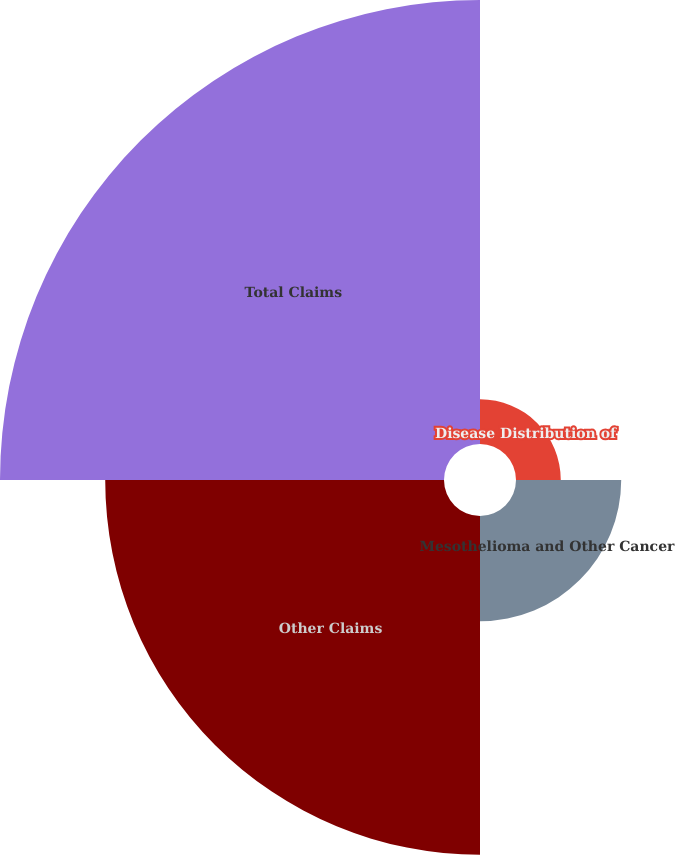<chart> <loc_0><loc_0><loc_500><loc_500><pie_chart><fcel>Disease Distribution of<fcel>Mesothelioma and Other Cancer<fcel>Other Claims<fcel>Total Claims<nl><fcel>4.8%<fcel>11.28%<fcel>36.32%<fcel>47.6%<nl></chart> 